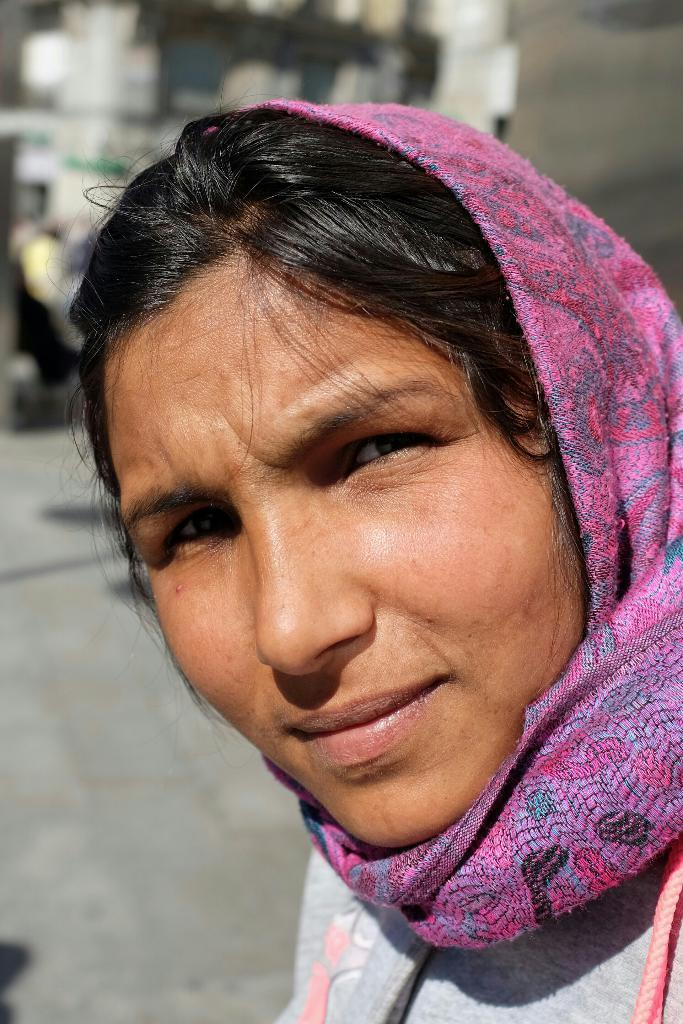What is the main subject of the image? The main subject of the image is a woman's face. What is the woman wearing in the image? The woman is wearing a scarf in the image. What is the name of the woman in the image? The provided facts do not include the name of the woman, so we cannot determine her name from the image. 